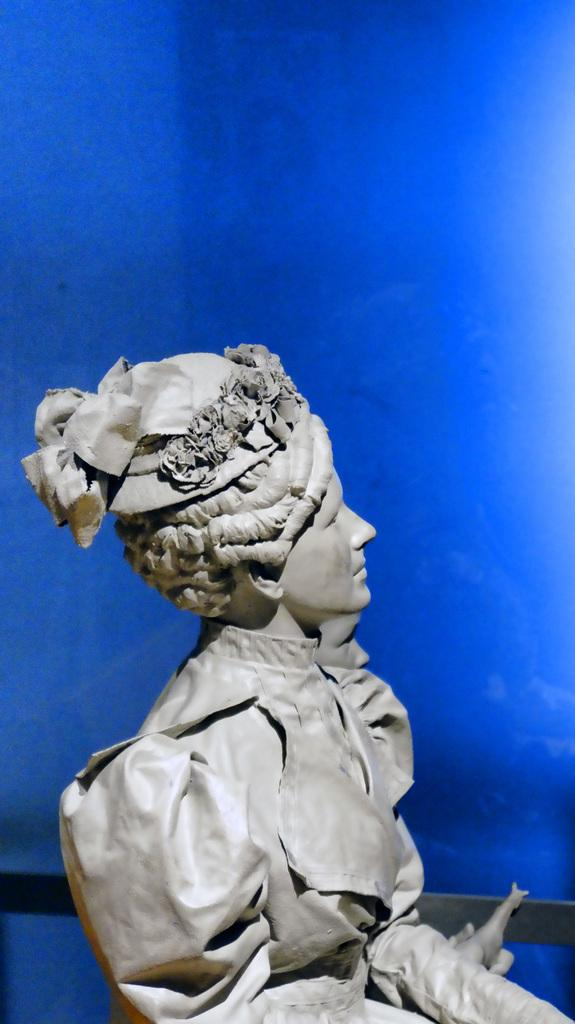What is the main subject in the image? There is a statue of a woman in the image. Can you describe the location of the statue in relation to other elements in the image? The statue is near a blue wall. What type of place is depicted in the image? The image does not depict a specific place; it only shows a statue of a woman near a blue wall. Can you tell me how many knots are tied on the statue's pocket? There is no pocket or knots present on the statue in the image. 